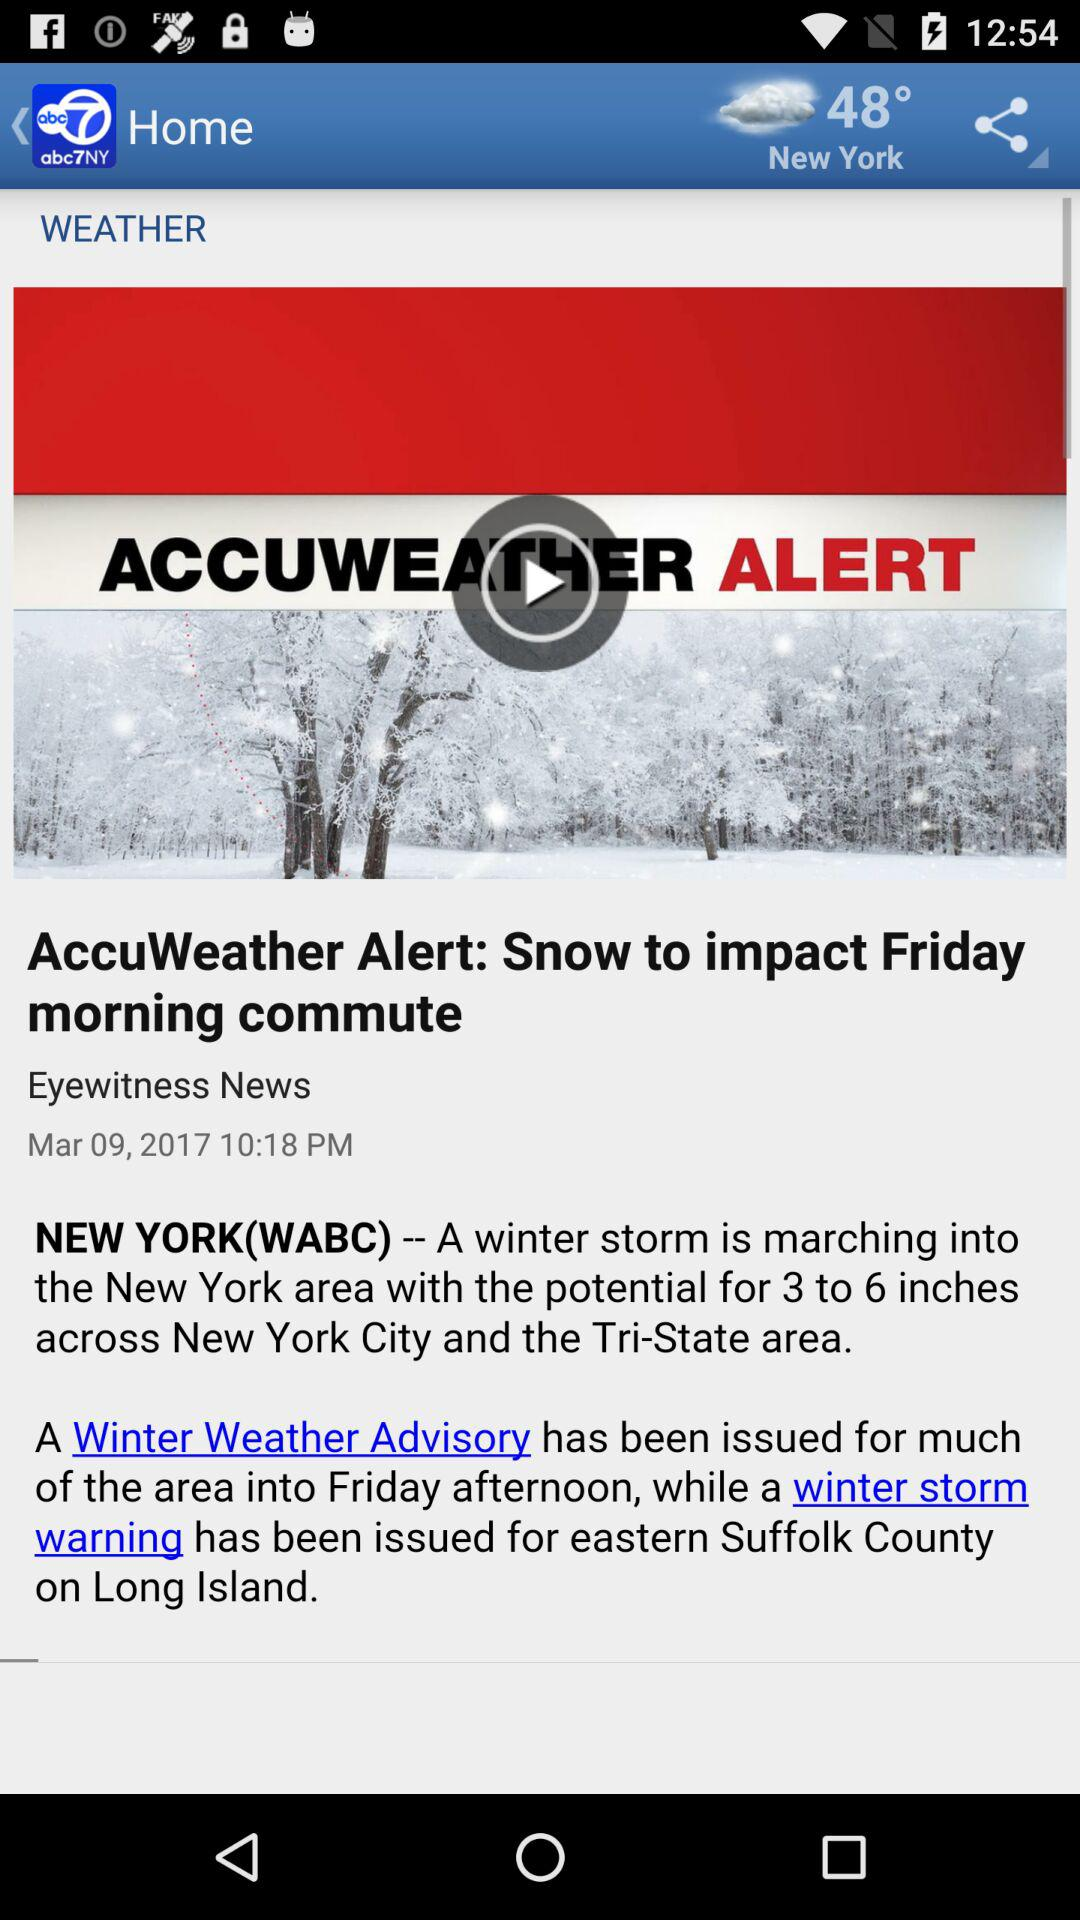What time has been given? The given time is 10:18 p.m. 